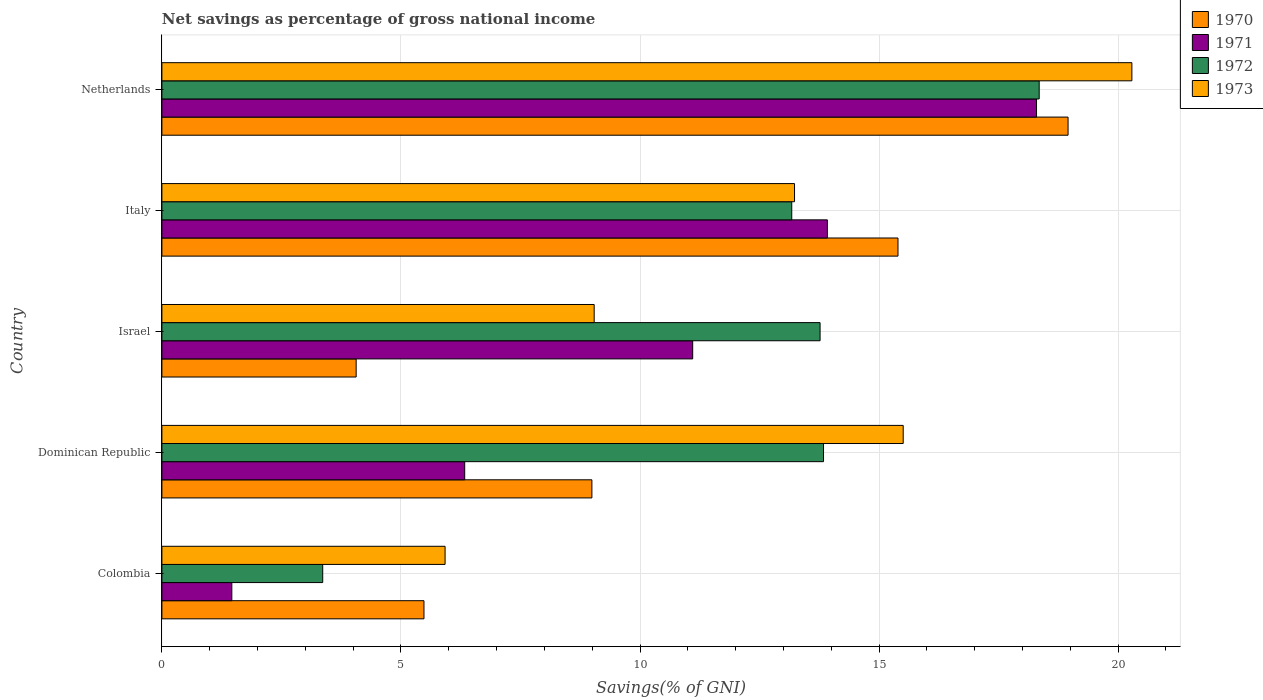How many different coloured bars are there?
Offer a very short reply. 4. Are the number of bars per tick equal to the number of legend labels?
Give a very brief answer. Yes. How many bars are there on the 4th tick from the bottom?
Offer a very short reply. 4. In how many cases, is the number of bars for a given country not equal to the number of legend labels?
Provide a short and direct response. 0. What is the total savings in 1971 in Italy?
Ensure brevity in your answer.  13.92. Across all countries, what is the maximum total savings in 1972?
Give a very brief answer. 18.35. Across all countries, what is the minimum total savings in 1970?
Your response must be concise. 4.06. In which country was the total savings in 1973 maximum?
Offer a very short reply. Netherlands. In which country was the total savings in 1973 minimum?
Your answer should be compact. Colombia. What is the total total savings in 1971 in the graph?
Offer a very short reply. 51.11. What is the difference between the total savings in 1972 in Colombia and that in Italy?
Your answer should be very brief. -9.81. What is the difference between the total savings in 1971 in Dominican Republic and the total savings in 1970 in Netherlands?
Your response must be concise. -12.62. What is the average total savings in 1970 per country?
Provide a succinct answer. 10.58. What is the difference between the total savings in 1973 and total savings in 1971 in Netherlands?
Offer a terse response. 1.99. In how many countries, is the total savings in 1972 greater than 20 %?
Offer a terse response. 0. What is the ratio of the total savings in 1970 in Dominican Republic to that in Israel?
Ensure brevity in your answer.  2.21. What is the difference between the highest and the second highest total savings in 1972?
Your answer should be compact. 4.51. What is the difference between the highest and the lowest total savings in 1970?
Give a very brief answer. 14.89. Is the sum of the total savings in 1973 in Dominican Republic and Italy greater than the maximum total savings in 1970 across all countries?
Offer a very short reply. Yes. How many countries are there in the graph?
Offer a very short reply. 5. What is the difference between two consecutive major ticks on the X-axis?
Keep it short and to the point. 5. Are the values on the major ticks of X-axis written in scientific E-notation?
Provide a succinct answer. No. Does the graph contain any zero values?
Give a very brief answer. No. How many legend labels are there?
Keep it short and to the point. 4. What is the title of the graph?
Provide a short and direct response. Net savings as percentage of gross national income. Does "2007" appear as one of the legend labels in the graph?
Your response must be concise. No. What is the label or title of the X-axis?
Offer a very short reply. Savings(% of GNI). What is the Savings(% of GNI) in 1970 in Colombia?
Your answer should be very brief. 5.48. What is the Savings(% of GNI) in 1971 in Colombia?
Keep it short and to the point. 1.46. What is the Savings(% of GNI) in 1972 in Colombia?
Keep it short and to the point. 3.36. What is the Savings(% of GNI) of 1973 in Colombia?
Keep it short and to the point. 5.92. What is the Savings(% of GNI) in 1970 in Dominican Republic?
Provide a succinct answer. 8.99. What is the Savings(% of GNI) in 1971 in Dominican Republic?
Offer a very short reply. 6.33. What is the Savings(% of GNI) of 1972 in Dominican Republic?
Ensure brevity in your answer.  13.84. What is the Savings(% of GNI) in 1973 in Dominican Republic?
Offer a very short reply. 15.5. What is the Savings(% of GNI) of 1970 in Israel?
Your answer should be compact. 4.06. What is the Savings(% of GNI) in 1971 in Israel?
Offer a very short reply. 11.1. What is the Savings(% of GNI) in 1972 in Israel?
Your answer should be compact. 13.77. What is the Savings(% of GNI) of 1973 in Israel?
Give a very brief answer. 9.04. What is the Savings(% of GNI) in 1970 in Italy?
Your response must be concise. 15.4. What is the Savings(% of GNI) in 1971 in Italy?
Your answer should be very brief. 13.92. What is the Savings(% of GNI) of 1972 in Italy?
Make the answer very short. 13.17. What is the Savings(% of GNI) in 1973 in Italy?
Your answer should be compact. 13.23. What is the Savings(% of GNI) in 1970 in Netherlands?
Offer a terse response. 18.95. What is the Savings(% of GNI) in 1971 in Netherlands?
Offer a terse response. 18.29. What is the Savings(% of GNI) in 1972 in Netherlands?
Offer a terse response. 18.35. What is the Savings(% of GNI) in 1973 in Netherlands?
Provide a short and direct response. 20.29. Across all countries, what is the maximum Savings(% of GNI) of 1970?
Provide a short and direct response. 18.95. Across all countries, what is the maximum Savings(% of GNI) in 1971?
Your answer should be compact. 18.29. Across all countries, what is the maximum Savings(% of GNI) of 1972?
Your answer should be very brief. 18.35. Across all countries, what is the maximum Savings(% of GNI) in 1973?
Your answer should be very brief. 20.29. Across all countries, what is the minimum Savings(% of GNI) in 1970?
Make the answer very short. 4.06. Across all countries, what is the minimum Savings(% of GNI) in 1971?
Your answer should be compact. 1.46. Across all countries, what is the minimum Savings(% of GNI) of 1972?
Offer a terse response. 3.36. Across all countries, what is the minimum Savings(% of GNI) in 1973?
Your answer should be compact. 5.92. What is the total Savings(% of GNI) in 1970 in the graph?
Keep it short and to the point. 52.89. What is the total Savings(% of GNI) of 1971 in the graph?
Provide a succinct answer. 51.11. What is the total Savings(% of GNI) in 1972 in the graph?
Offer a terse response. 62.49. What is the total Savings(% of GNI) of 1973 in the graph?
Your answer should be very brief. 63.99. What is the difference between the Savings(% of GNI) in 1970 in Colombia and that in Dominican Republic?
Your answer should be compact. -3.51. What is the difference between the Savings(% of GNI) in 1971 in Colombia and that in Dominican Republic?
Give a very brief answer. -4.87. What is the difference between the Savings(% of GNI) of 1972 in Colombia and that in Dominican Republic?
Provide a short and direct response. -10.47. What is the difference between the Savings(% of GNI) of 1973 in Colombia and that in Dominican Republic?
Give a very brief answer. -9.58. What is the difference between the Savings(% of GNI) of 1970 in Colombia and that in Israel?
Provide a short and direct response. 1.42. What is the difference between the Savings(% of GNI) of 1971 in Colombia and that in Israel?
Keep it short and to the point. -9.64. What is the difference between the Savings(% of GNI) of 1972 in Colombia and that in Israel?
Your answer should be compact. -10.4. What is the difference between the Savings(% of GNI) in 1973 in Colombia and that in Israel?
Offer a terse response. -3.12. What is the difference between the Savings(% of GNI) in 1970 in Colombia and that in Italy?
Offer a very short reply. -9.91. What is the difference between the Savings(% of GNI) of 1971 in Colombia and that in Italy?
Ensure brevity in your answer.  -12.46. What is the difference between the Savings(% of GNI) of 1972 in Colombia and that in Italy?
Provide a succinct answer. -9.81. What is the difference between the Savings(% of GNI) in 1973 in Colombia and that in Italy?
Ensure brevity in your answer.  -7.31. What is the difference between the Savings(% of GNI) of 1970 in Colombia and that in Netherlands?
Make the answer very short. -13.47. What is the difference between the Savings(% of GNI) of 1971 in Colombia and that in Netherlands?
Make the answer very short. -16.83. What is the difference between the Savings(% of GNI) in 1972 in Colombia and that in Netherlands?
Offer a terse response. -14.99. What is the difference between the Savings(% of GNI) of 1973 in Colombia and that in Netherlands?
Keep it short and to the point. -14.36. What is the difference between the Savings(% of GNI) in 1970 in Dominican Republic and that in Israel?
Offer a very short reply. 4.93. What is the difference between the Savings(% of GNI) of 1971 in Dominican Republic and that in Israel?
Provide a short and direct response. -4.77. What is the difference between the Savings(% of GNI) of 1972 in Dominican Republic and that in Israel?
Your answer should be compact. 0.07. What is the difference between the Savings(% of GNI) in 1973 in Dominican Republic and that in Israel?
Offer a terse response. 6.46. What is the difference between the Savings(% of GNI) of 1970 in Dominican Republic and that in Italy?
Give a very brief answer. -6.4. What is the difference between the Savings(% of GNI) in 1971 in Dominican Republic and that in Italy?
Your answer should be compact. -7.59. What is the difference between the Savings(% of GNI) in 1972 in Dominican Republic and that in Italy?
Keep it short and to the point. 0.66. What is the difference between the Savings(% of GNI) in 1973 in Dominican Republic and that in Italy?
Give a very brief answer. 2.27. What is the difference between the Savings(% of GNI) in 1970 in Dominican Republic and that in Netherlands?
Provide a short and direct response. -9.96. What is the difference between the Savings(% of GNI) of 1971 in Dominican Republic and that in Netherlands?
Offer a terse response. -11.96. What is the difference between the Savings(% of GNI) of 1972 in Dominican Republic and that in Netherlands?
Your answer should be compact. -4.51. What is the difference between the Savings(% of GNI) in 1973 in Dominican Republic and that in Netherlands?
Your answer should be compact. -4.78. What is the difference between the Savings(% of GNI) of 1970 in Israel and that in Italy?
Your response must be concise. -11.33. What is the difference between the Savings(% of GNI) in 1971 in Israel and that in Italy?
Provide a short and direct response. -2.82. What is the difference between the Savings(% of GNI) in 1972 in Israel and that in Italy?
Give a very brief answer. 0.59. What is the difference between the Savings(% of GNI) of 1973 in Israel and that in Italy?
Provide a succinct answer. -4.19. What is the difference between the Savings(% of GNI) in 1970 in Israel and that in Netherlands?
Your response must be concise. -14.89. What is the difference between the Savings(% of GNI) in 1971 in Israel and that in Netherlands?
Ensure brevity in your answer.  -7.19. What is the difference between the Savings(% of GNI) in 1972 in Israel and that in Netherlands?
Your answer should be compact. -4.58. What is the difference between the Savings(% of GNI) in 1973 in Israel and that in Netherlands?
Your response must be concise. -11.25. What is the difference between the Savings(% of GNI) in 1970 in Italy and that in Netherlands?
Offer a terse response. -3.56. What is the difference between the Savings(% of GNI) of 1971 in Italy and that in Netherlands?
Offer a very short reply. -4.37. What is the difference between the Savings(% of GNI) of 1972 in Italy and that in Netherlands?
Keep it short and to the point. -5.18. What is the difference between the Savings(% of GNI) of 1973 in Italy and that in Netherlands?
Provide a short and direct response. -7.06. What is the difference between the Savings(% of GNI) in 1970 in Colombia and the Savings(% of GNI) in 1971 in Dominican Republic?
Ensure brevity in your answer.  -0.85. What is the difference between the Savings(% of GNI) of 1970 in Colombia and the Savings(% of GNI) of 1972 in Dominican Republic?
Give a very brief answer. -8.36. What is the difference between the Savings(% of GNI) in 1970 in Colombia and the Savings(% of GNI) in 1973 in Dominican Republic?
Ensure brevity in your answer.  -10.02. What is the difference between the Savings(% of GNI) of 1971 in Colombia and the Savings(% of GNI) of 1972 in Dominican Republic?
Offer a terse response. -12.38. What is the difference between the Savings(% of GNI) in 1971 in Colombia and the Savings(% of GNI) in 1973 in Dominican Republic?
Keep it short and to the point. -14.04. What is the difference between the Savings(% of GNI) in 1972 in Colombia and the Savings(% of GNI) in 1973 in Dominican Republic?
Keep it short and to the point. -12.14. What is the difference between the Savings(% of GNI) in 1970 in Colombia and the Savings(% of GNI) in 1971 in Israel?
Offer a very short reply. -5.62. What is the difference between the Savings(% of GNI) in 1970 in Colombia and the Savings(% of GNI) in 1972 in Israel?
Provide a succinct answer. -8.28. What is the difference between the Savings(% of GNI) in 1970 in Colombia and the Savings(% of GNI) in 1973 in Israel?
Offer a very short reply. -3.56. What is the difference between the Savings(% of GNI) in 1971 in Colombia and the Savings(% of GNI) in 1972 in Israel?
Keep it short and to the point. -12.3. What is the difference between the Savings(% of GNI) in 1971 in Colombia and the Savings(% of GNI) in 1973 in Israel?
Your answer should be compact. -7.58. What is the difference between the Savings(% of GNI) in 1972 in Colombia and the Savings(% of GNI) in 1973 in Israel?
Provide a succinct answer. -5.68. What is the difference between the Savings(% of GNI) in 1970 in Colombia and the Savings(% of GNI) in 1971 in Italy?
Ensure brevity in your answer.  -8.44. What is the difference between the Savings(% of GNI) in 1970 in Colombia and the Savings(% of GNI) in 1972 in Italy?
Give a very brief answer. -7.69. What is the difference between the Savings(% of GNI) in 1970 in Colombia and the Savings(% of GNI) in 1973 in Italy?
Give a very brief answer. -7.75. What is the difference between the Savings(% of GNI) in 1971 in Colombia and the Savings(% of GNI) in 1972 in Italy?
Keep it short and to the point. -11.71. What is the difference between the Savings(% of GNI) in 1971 in Colombia and the Savings(% of GNI) in 1973 in Italy?
Provide a succinct answer. -11.77. What is the difference between the Savings(% of GNI) of 1972 in Colombia and the Savings(% of GNI) of 1973 in Italy?
Provide a succinct answer. -9.87. What is the difference between the Savings(% of GNI) in 1970 in Colombia and the Savings(% of GNI) in 1971 in Netherlands?
Offer a very short reply. -12.81. What is the difference between the Savings(% of GNI) in 1970 in Colombia and the Savings(% of GNI) in 1972 in Netherlands?
Offer a very short reply. -12.87. What is the difference between the Savings(% of GNI) in 1970 in Colombia and the Savings(% of GNI) in 1973 in Netherlands?
Offer a terse response. -14.81. What is the difference between the Savings(% of GNI) of 1971 in Colombia and the Savings(% of GNI) of 1972 in Netherlands?
Ensure brevity in your answer.  -16.89. What is the difference between the Savings(% of GNI) of 1971 in Colombia and the Savings(% of GNI) of 1973 in Netherlands?
Your answer should be very brief. -18.83. What is the difference between the Savings(% of GNI) of 1972 in Colombia and the Savings(% of GNI) of 1973 in Netherlands?
Your answer should be very brief. -16.92. What is the difference between the Savings(% of GNI) in 1970 in Dominican Republic and the Savings(% of GNI) in 1971 in Israel?
Your response must be concise. -2.11. What is the difference between the Savings(% of GNI) of 1970 in Dominican Republic and the Savings(% of GNI) of 1972 in Israel?
Your answer should be compact. -4.77. What is the difference between the Savings(% of GNI) in 1970 in Dominican Republic and the Savings(% of GNI) in 1973 in Israel?
Your answer should be compact. -0.05. What is the difference between the Savings(% of GNI) of 1971 in Dominican Republic and the Savings(% of GNI) of 1972 in Israel?
Offer a very short reply. -7.43. What is the difference between the Savings(% of GNI) of 1971 in Dominican Republic and the Savings(% of GNI) of 1973 in Israel?
Your answer should be compact. -2.71. What is the difference between the Savings(% of GNI) in 1972 in Dominican Republic and the Savings(% of GNI) in 1973 in Israel?
Your response must be concise. 4.8. What is the difference between the Savings(% of GNI) in 1970 in Dominican Republic and the Savings(% of GNI) in 1971 in Italy?
Your answer should be compact. -4.93. What is the difference between the Savings(% of GNI) in 1970 in Dominican Republic and the Savings(% of GNI) in 1972 in Italy?
Offer a terse response. -4.18. What is the difference between the Savings(% of GNI) in 1970 in Dominican Republic and the Savings(% of GNI) in 1973 in Italy?
Provide a succinct answer. -4.24. What is the difference between the Savings(% of GNI) of 1971 in Dominican Republic and the Savings(% of GNI) of 1972 in Italy?
Give a very brief answer. -6.84. What is the difference between the Savings(% of GNI) of 1971 in Dominican Republic and the Savings(% of GNI) of 1973 in Italy?
Ensure brevity in your answer.  -6.9. What is the difference between the Savings(% of GNI) of 1972 in Dominican Republic and the Savings(% of GNI) of 1973 in Italy?
Your answer should be very brief. 0.61. What is the difference between the Savings(% of GNI) of 1970 in Dominican Republic and the Savings(% of GNI) of 1971 in Netherlands?
Your response must be concise. -9.3. What is the difference between the Savings(% of GNI) of 1970 in Dominican Republic and the Savings(% of GNI) of 1972 in Netherlands?
Provide a short and direct response. -9.36. What is the difference between the Savings(% of GNI) of 1970 in Dominican Republic and the Savings(% of GNI) of 1973 in Netherlands?
Your answer should be compact. -11.29. What is the difference between the Savings(% of GNI) in 1971 in Dominican Republic and the Savings(% of GNI) in 1972 in Netherlands?
Make the answer very short. -12.02. What is the difference between the Savings(% of GNI) of 1971 in Dominican Republic and the Savings(% of GNI) of 1973 in Netherlands?
Keep it short and to the point. -13.95. What is the difference between the Savings(% of GNI) of 1972 in Dominican Republic and the Savings(% of GNI) of 1973 in Netherlands?
Your answer should be very brief. -6.45. What is the difference between the Savings(% of GNI) in 1970 in Israel and the Savings(% of GNI) in 1971 in Italy?
Provide a succinct answer. -9.86. What is the difference between the Savings(% of GNI) of 1970 in Israel and the Savings(% of GNI) of 1972 in Italy?
Provide a succinct answer. -9.11. What is the difference between the Savings(% of GNI) of 1970 in Israel and the Savings(% of GNI) of 1973 in Italy?
Provide a short and direct response. -9.17. What is the difference between the Savings(% of GNI) of 1971 in Israel and the Savings(% of GNI) of 1972 in Italy?
Ensure brevity in your answer.  -2.07. What is the difference between the Savings(% of GNI) in 1971 in Israel and the Savings(% of GNI) in 1973 in Italy?
Give a very brief answer. -2.13. What is the difference between the Savings(% of GNI) in 1972 in Israel and the Savings(% of GNI) in 1973 in Italy?
Offer a terse response. 0.53. What is the difference between the Savings(% of GNI) of 1970 in Israel and the Savings(% of GNI) of 1971 in Netherlands?
Give a very brief answer. -14.23. What is the difference between the Savings(% of GNI) in 1970 in Israel and the Savings(% of GNI) in 1972 in Netherlands?
Ensure brevity in your answer.  -14.29. What is the difference between the Savings(% of GNI) of 1970 in Israel and the Savings(% of GNI) of 1973 in Netherlands?
Ensure brevity in your answer.  -16.22. What is the difference between the Savings(% of GNI) of 1971 in Israel and the Savings(% of GNI) of 1972 in Netherlands?
Offer a very short reply. -7.25. What is the difference between the Savings(% of GNI) in 1971 in Israel and the Savings(% of GNI) in 1973 in Netherlands?
Ensure brevity in your answer.  -9.19. What is the difference between the Savings(% of GNI) in 1972 in Israel and the Savings(% of GNI) in 1973 in Netherlands?
Your response must be concise. -6.52. What is the difference between the Savings(% of GNI) in 1970 in Italy and the Savings(% of GNI) in 1971 in Netherlands?
Your answer should be very brief. -2.9. What is the difference between the Savings(% of GNI) of 1970 in Italy and the Savings(% of GNI) of 1972 in Netherlands?
Your answer should be compact. -2.95. What is the difference between the Savings(% of GNI) in 1970 in Italy and the Savings(% of GNI) in 1973 in Netherlands?
Make the answer very short. -4.89. What is the difference between the Savings(% of GNI) in 1971 in Italy and the Savings(% of GNI) in 1972 in Netherlands?
Offer a terse response. -4.43. What is the difference between the Savings(% of GNI) of 1971 in Italy and the Savings(% of GNI) of 1973 in Netherlands?
Offer a terse response. -6.37. What is the difference between the Savings(% of GNI) in 1972 in Italy and the Savings(% of GNI) in 1973 in Netherlands?
Your answer should be very brief. -7.11. What is the average Savings(% of GNI) of 1970 per country?
Offer a terse response. 10.58. What is the average Savings(% of GNI) in 1971 per country?
Your response must be concise. 10.22. What is the average Savings(% of GNI) of 1972 per country?
Provide a succinct answer. 12.5. What is the average Savings(% of GNI) in 1973 per country?
Make the answer very short. 12.8. What is the difference between the Savings(% of GNI) of 1970 and Savings(% of GNI) of 1971 in Colombia?
Provide a short and direct response. 4.02. What is the difference between the Savings(% of GNI) in 1970 and Savings(% of GNI) in 1972 in Colombia?
Offer a very short reply. 2.12. What is the difference between the Savings(% of GNI) of 1970 and Savings(% of GNI) of 1973 in Colombia?
Your answer should be very brief. -0.44. What is the difference between the Savings(% of GNI) of 1971 and Savings(% of GNI) of 1972 in Colombia?
Offer a very short reply. -1.9. What is the difference between the Savings(% of GNI) of 1971 and Savings(% of GNI) of 1973 in Colombia?
Provide a succinct answer. -4.46. What is the difference between the Savings(% of GNI) of 1972 and Savings(% of GNI) of 1973 in Colombia?
Your answer should be very brief. -2.56. What is the difference between the Savings(% of GNI) in 1970 and Savings(% of GNI) in 1971 in Dominican Republic?
Offer a very short reply. 2.66. What is the difference between the Savings(% of GNI) in 1970 and Savings(% of GNI) in 1972 in Dominican Republic?
Your answer should be compact. -4.84. What is the difference between the Savings(% of GNI) in 1970 and Savings(% of GNI) in 1973 in Dominican Republic?
Offer a very short reply. -6.51. What is the difference between the Savings(% of GNI) of 1971 and Savings(% of GNI) of 1972 in Dominican Republic?
Offer a terse response. -7.5. What is the difference between the Savings(% of GNI) of 1971 and Savings(% of GNI) of 1973 in Dominican Republic?
Ensure brevity in your answer.  -9.17. What is the difference between the Savings(% of GNI) of 1972 and Savings(% of GNI) of 1973 in Dominican Republic?
Ensure brevity in your answer.  -1.67. What is the difference between the Savings(% of GNI) of 1970 and Savings(% of GNI) of 1971 in Israel?
Your answer should be compact. -7.04. What is the difference between the Savings(% of GNI) of 1970 and Savings(% of GNI) of 1972 in Israel?
Provide a succinct answer. -9.7. What is the difference between the Savings(% of GNI) of 1970 and Savings(% of GNI) of 1973 in Israel?
Ensure brevity in your answer.  -4.98. What is the difference between the Savings(% of GNI) in 1971 and Savings(% of GNI) in 1972 in Israel?
Offer a terse response. -2.66. What is the difference between the Savings(% of GNI) in 1971 and Savings(% of GNI) in 1973 in Israel?
Your response must be concise. 2.06. What is the difference between the Savings(% of GNI) of 1972 and Savings(% of GNI) of 1973 in Israel?
Your response must be concise. 4.73. What is the difference between the Savings(% of GNI) of 1970 and Savings(% of GNI) of 1971 in Italy?
Your answer should be compact. 1.48. What is the difference between the Savings(% of GNI) in 1970 and Savings(% of GNI) in 1972 in Italy?
Give a very brief answer. 2.22. What is the difference between the Savings(% of GNI) of 1970 and Savings(% of GNI) of 1973 in Italy?
Keep it short and to the point. 2.16. What is the difference between the Savings(% of GNI) in 1971 and Savings(% of GNI) in 1972 in Italy?
Provide a short and direct response. 0.75. What is the difference between the Savings(% of GNI) in 1971 and Savings(% of GNI) in 1973 in Italy?
Provide a succinct answer. 0.69. What is the difference between the Savings(% of GNI) in 1972 and Savings(% of GNI) in 1973 in Italy?
Your answer should be compact. -0.06. What is the difference between the Savings(% of GNI) of 1970 and Savings(% of GNI) of 1971 in Netherlands?
Your response must be concise. 0.66. What is the difference between the Savings(% of GNI) in 1970 and Savings(% of GNI) in 1972 in Netherlands?
Give a very brief answer. 0.6. What is the difference between the Savings(% of GNI) of 1970 and Savings(% of GNI) of 1973 in Netherlands?
Your response must be concise. -1.33. What is the difference between the Savings(% of GNI) in 1971 and Savings(% of GNI) in 1972 in Netherlands?
Give a very brief answer. -0.06. What is the difference between the Savings(% of GNI) in 1971 and Savings(% of GNI) in 1973 in Netherlands?
Provide a succinct answer. -1.99. What is the difference between the Savings(% of GNI) in 1972 and Savings(% of GNI) in 1973 in Netherlands?
Ensure brevity in your answer.  -1.94. What is the ratio of the Savings(% of GNI) in 1970 in Colombia to that in Dominican Republic?
Give a very brief answer. 0.61. What is the ratio of the Savings(% of GNI) of 1971 in Colombia to that in Dominican Republic?
Your response must be concise. 0.23. What is the ratio of the Savings(% of GNI) in 1972 in Colombia to that in Dominican Republic?
Give a very brief answer. 0.24. What is the ratio of the Savings(% of GNI) of 1973 in Colombia to that in Dominican Republic?
Your response must be concise. 0.38. What is the ratio of the Savings(% of GNI) of 1970 in Colombia to that in Israel?
Ensure brevity in your answer.  1.35. What is the ratio of the Savings(% of GNI) of 1971 in Colombia to that in Israel?
Offer a terse response. 0.13. What is the ratio of the Savings(% of GNI) of 1972 in Colombia to that in Israel?
Offer a terse response. 0.24. What is the ratio of the Savings(% of GNI) in 1973 in Colombia to that in Israel?
Your response must be concise. 0.66. What is the ratio of the Savings(% of GNI) in 1970 in Colombia to that in Italy?
Your answer should be compact. 0.36. What is the ratio of the Savings(% of GNI) in 1971 in Colombia to that in Italy?
Offer a very short reply. 0.11. What is the ratio of the Savings(% of GNI) of 1972 in Colombia to that in Italy?
Keep it short and to the point. 0.26. What is the ratio of the Savings(% of GNI) of 1973 in Colombia to that in Italy?
Offer a very short reply. 0.45. What is the ratio of the Savings(% of GNI) in 1970 in Colombia to that in Netherlands?
Make the answer very short. 0.29. What is the ratio of the Savings(% of GNI) in 1971 in Colombia to that in Netherlands?
Offer a very short reply. 0.08. What is the ratio of the Savings(% of GNI) of 1972 in Colombia to that in Netherlands?
Your answer should be compact. 0.18. What is the ratio of the Savings(% of GNI) of 1973 in Colombia to that in Netherlands?
Give a very brief answer. 0.29. What is the ratio of the Savings(% of GNI) in 1970 in Dominican Republic to that in Israel?
Your answer should be compact. 2.21. What is the ratio of the Savings(% of GNI) of 1971 in Dominican Republic to that in Israel?
Provide a short and direct response. 0.57. What is the ratio of the Savings(% of GNI) of 1972 in Dominican Republic to that in Israel?
Your answer should be very brief. 1.01. What is the ratio of the Savings(% of GNI) of 1973 in Dominican Republic to that in Israel?
Provide a succinct answer. 1.71. What is the ratio of the Savings(% of GNI) in 1970 in Dominican Republic to that in Italy?
Provide a short and direct response. 0.58. What is the ratio of the Savings(% of GNI) of 1971 in Dominican Republic to that in Italy?
Offer a terse response. 0.46. What is the ratio of the Savings(% of GNI) in 1972 in Dominican Republic to that in Italy?
Your response must be concise. 1.05. What is the ratio of the Savings(% of GNI) in 1973 in Dominican Republic to that in Italy?
Ensure brevity in your answer.  1.17. What is the ratio of the Savings(% of GNI) in 1970 in Dominican Republic to that in Netherlands?
Keep it short and to the point. 0.47. What is the ratio of the Savings(% of GNI) in 1971 in Dominican Republic to that in Netherlands?
Make the answer very short. 0.35. What is the ratio of the Savings(% of GNI) of 1972 in Dominican Republic to that in Netherlands?
Offer a terse response. 0.75. What is the ratio of the Savings(% of GNI) in 1973 in Dominican Republic to that in Netherlands?
Your answer should be very brief. 0.76. What is the ratio of the Savings(% of GNI) of 1970 in Israel to that in Italy?
Offer a terse response. 0.26. What is the ratio of the Savings(% of GNI) in 1971 in Israel to that in Italy?
Ensure brevity in your answer.  0.8. What is the ratio of the Savings(% of GNI) of 1972 in Israel to that in Italy?
Keep it short and to the point. 1.04. What is the ratio of the Savings(% of GNI) in 1973 in Israel to that in Italy?
Give a very brief answer. 0.68. What is the ratio of the Savings(% of GNI) of 1970 in Israel to that in Netherlands?
Make the answer very short. 0.21. What is the ratio of the Savings(% of GNI) of 1971 in Israel to that in Netherlands?
Provide a short and direct response. 0.61. What is the ratio of the Savings(% of GNI) in 1972 in Israel to that in Netherlands?
Offer a very short reply. 0.75. What is the ratio of the Savings(% of GNI) of 1973 in Israel to that in Netherlands?
Provide a short and direct response. 0.45. What is the ratio of the Savings(% of GNI) in 1970 in Italy to that in Netherlands?
Provide a succinct answer. 0.81. What is the ratio of the Savings(% of GNI) in 1971 in Italy to that in Netherlands?
Your answer should be compact. 0.76. What is the ratio of the Savings(% of GNI) of 1972 in Italy to that in Netherlands?
Offer a terse response. 0.72. What is the ratio of the Savings(% of GNI) in 1973 in Italy to that in Netherlands?
Make the answer very short. 0.65. What is the difference between the highest and the second highest Savings(% of GNI) in 1970?
Make the answer very short. 3.56. What is the difference between the highest and the second highest Savings(% of GNI) in 1971?
Your answer should be very brief. 4.37. What is the difference between the highest and the second highest Savings(% of GNI) in 1972?
Make the answer very short. 4.51. What is the difference between the highest and the second highest Savings(% of GNI) of 1973?
Your response must be concise. 4.78. What is the difference between the highest and the lowest Savings(% of GNI) of 1970?
Your response must be concise. 14.89. What is the difference between the highest and the lowest Savings(% of GNI) of 1971?
Your answer should be very brief. 16.83. What is the difference between the highest and the lowest Savings(% of GNI) in 1972?
Keep it short and to the point. 14.99. What is the difference between the highest and the lowest Savings(% of GNI) of 1973?
Provide a succinct answer. 14.36. 